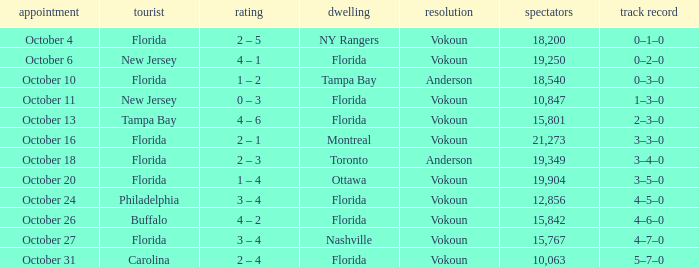What was the score on October 13? 4 – 6. 